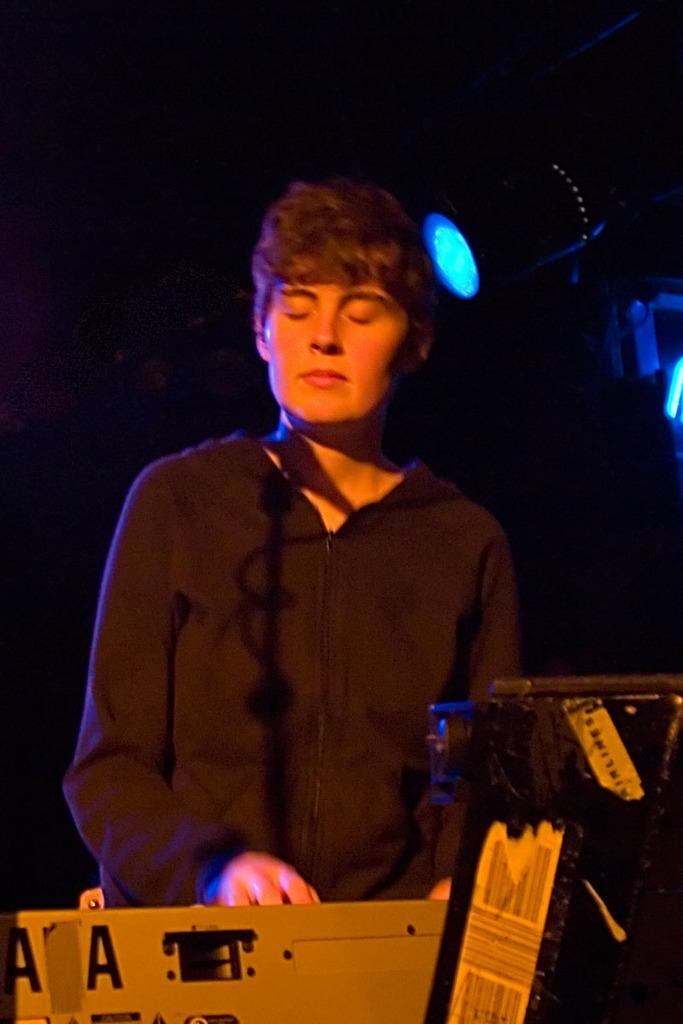What is the main subject of the image? There is a person standing in the image. What is in front of the person? There are objects in front of the person. Where are the lights located in the image? The lights are on the right side of the image. What type of string is being used to hold up the produce in the image? There is no produce or string present in the image. What type of sail can be seen in the image? There is no sail present in the image. 